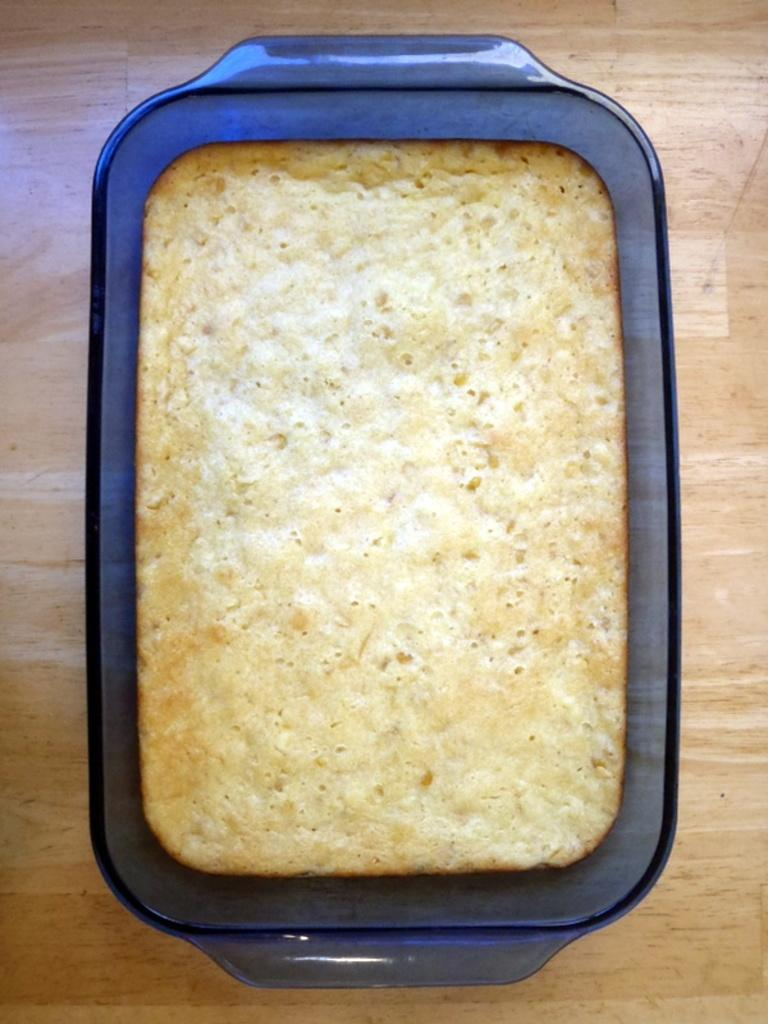What type of food is on the tray in the image? There is bread on a tray in the image. Where is the tray with bread located in the image? The tray with bread is on a table at the bottom of the image. What type of duck is swimming in the image? There is no duck present in the image, so it is not possible to determine the type of duck. 